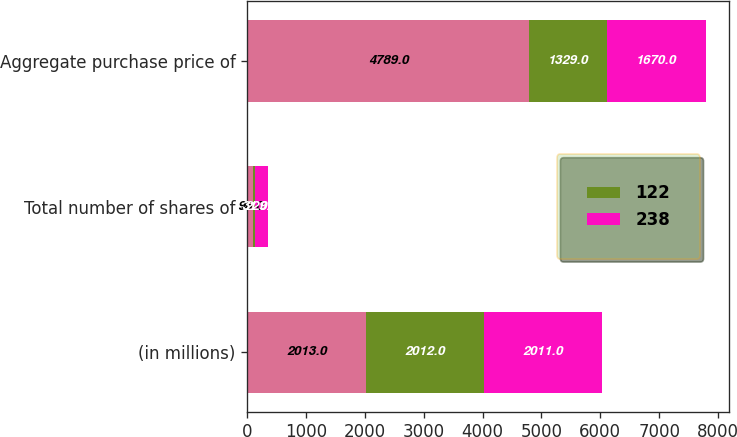<chart> <loc_0><loc_0><loc_500><loc_500><stacked_bar_chart><ecel><fcel>(in millions)<fcel>Total number of shares of<fcel>Aggregate purchase price of<nl><fcel>nan<fcel>2013<fcel>96<fcel>4789<nl><fcel>122<fcel>2012<fcel>31<fcel>1329<nl><fcel>238<fcel>2011<fcel>229<fcel>1670<nl></chart> 